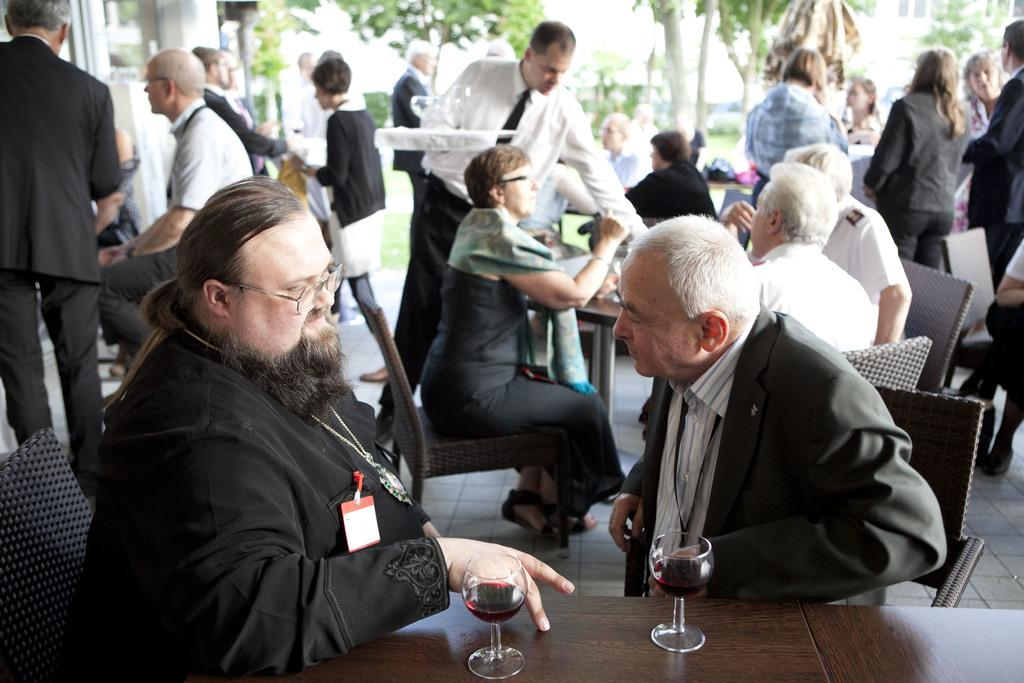What are the people in the image doing? There is a group of people sitting on chairs in the image. What is in front of the people sitting on chairs? The chairs are in front of a table. What else can be seen happening in the image? There are men walking on the floor. What type of grass is growing on the floor in the image? There is no grass present in the image; it features a group of people sitting on chairs, a table, and men walking on the floor. What joke is being told by the people sitting on chairs? There is no joke being told in the image; it simply shows people sitting on chairs and men walking on the floor. 